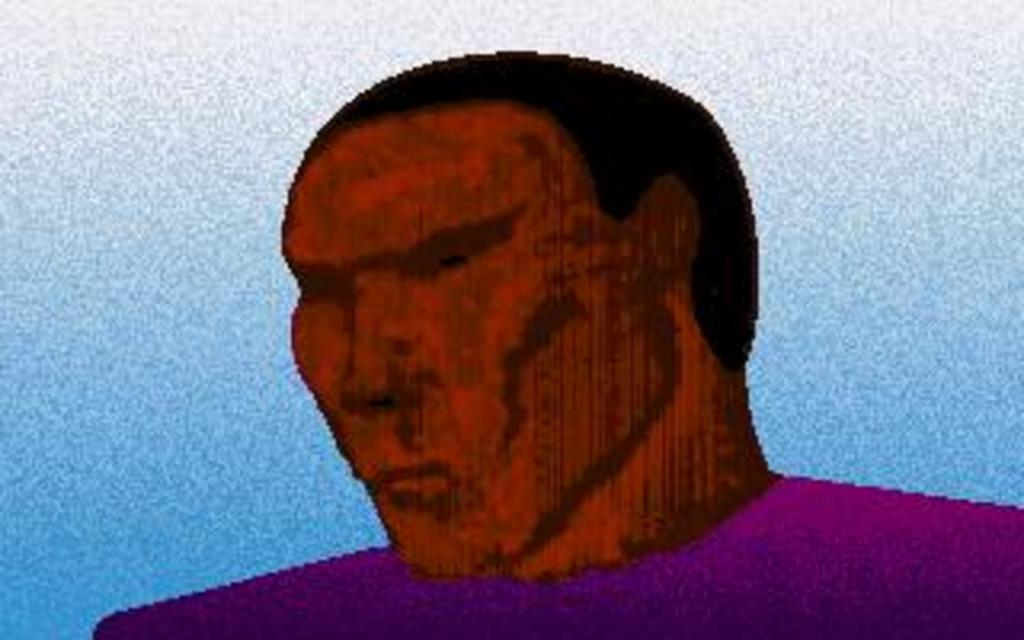What is depicted in the painting in the image? There is a painting of a man in the image. What color is the background of the painting? The background of the image is blue. Where is the alley located in the image? There is no alley present in the image; it only features a painting of a man with a blue background. 